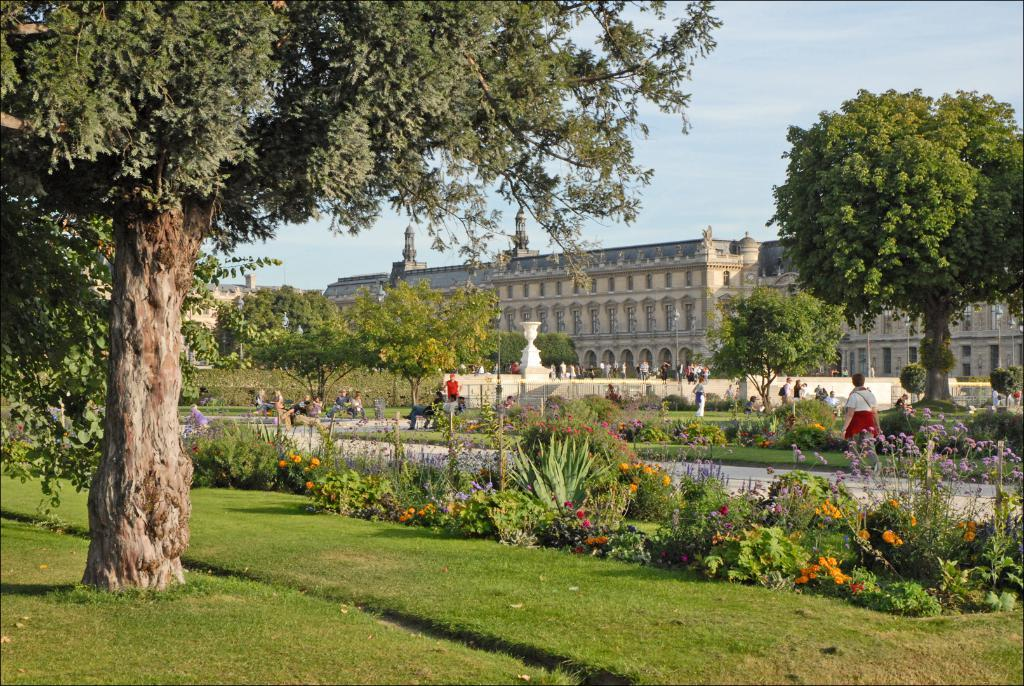What type of vegetation can be seen in the image? There are plants and trees in the image. What type of structure is present in the image? There is a building in the image. What is the person in the image doing? The person is walking on the road in the image. Where are the people in the image sitting? The people are sitting on a bench in the image. What can be seen in the background of the image? The sky is visible in the background of the image. What type of music is being played during the recess in the image? There is no mention of a recess or music in the image; it features plants, trees, a building, a person walking, people sitting on a bench, and a visible sky in the background. 